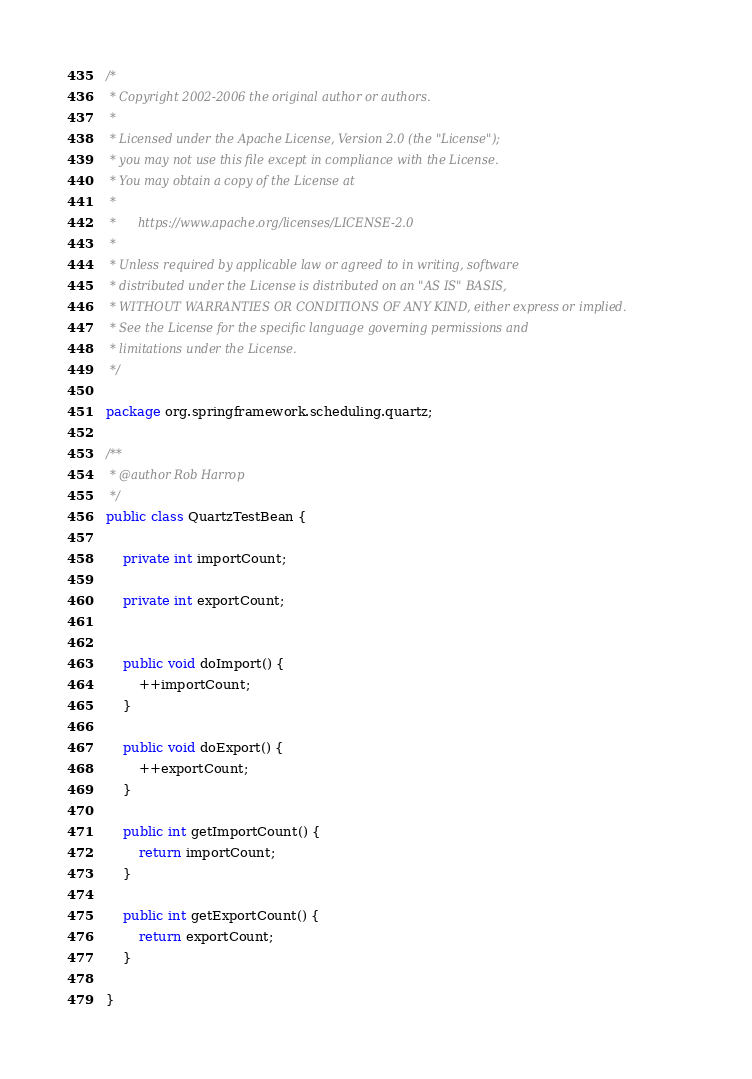<code> <loc_0><loc_0><loc_500><loc_500><_Java_>/*
 * Copyright 2002-2006 the original author or authors.
 *
 * Licensed under the Apache License, Version 2.0 (the "License");
 * you may not use this file except in compliance with the License.
 * You may obtain a copy of the License at
 *
 *      https://www.apache.org/licenses/LICENSE-2.0
 *
 * Unless required by applicable law or agreed to in writing, software
 * distributed under the License is distributed on an "AS IS" BASIS,
 * WITHOUT WARRANTIES OR CONDITIONS OF ANY KIND, either express or implied.
 * See the License for the specific language governing permissions and
 * limitations under the License.
 */

package org.springframework.scheduling.quartz;

/**
 * @author Rob Harrop
 */
public class QuartzTestBean {

    private int importCount;

    private int exportCount;


    public void doImport() {
        ++importCount;
    }

    public void doExport() {
        ++exportCount;
    }

    public int getImportCount() {
        return importCount;
    }

    public int getExportCount() {
        return exportCount;
    }

}
</code> 